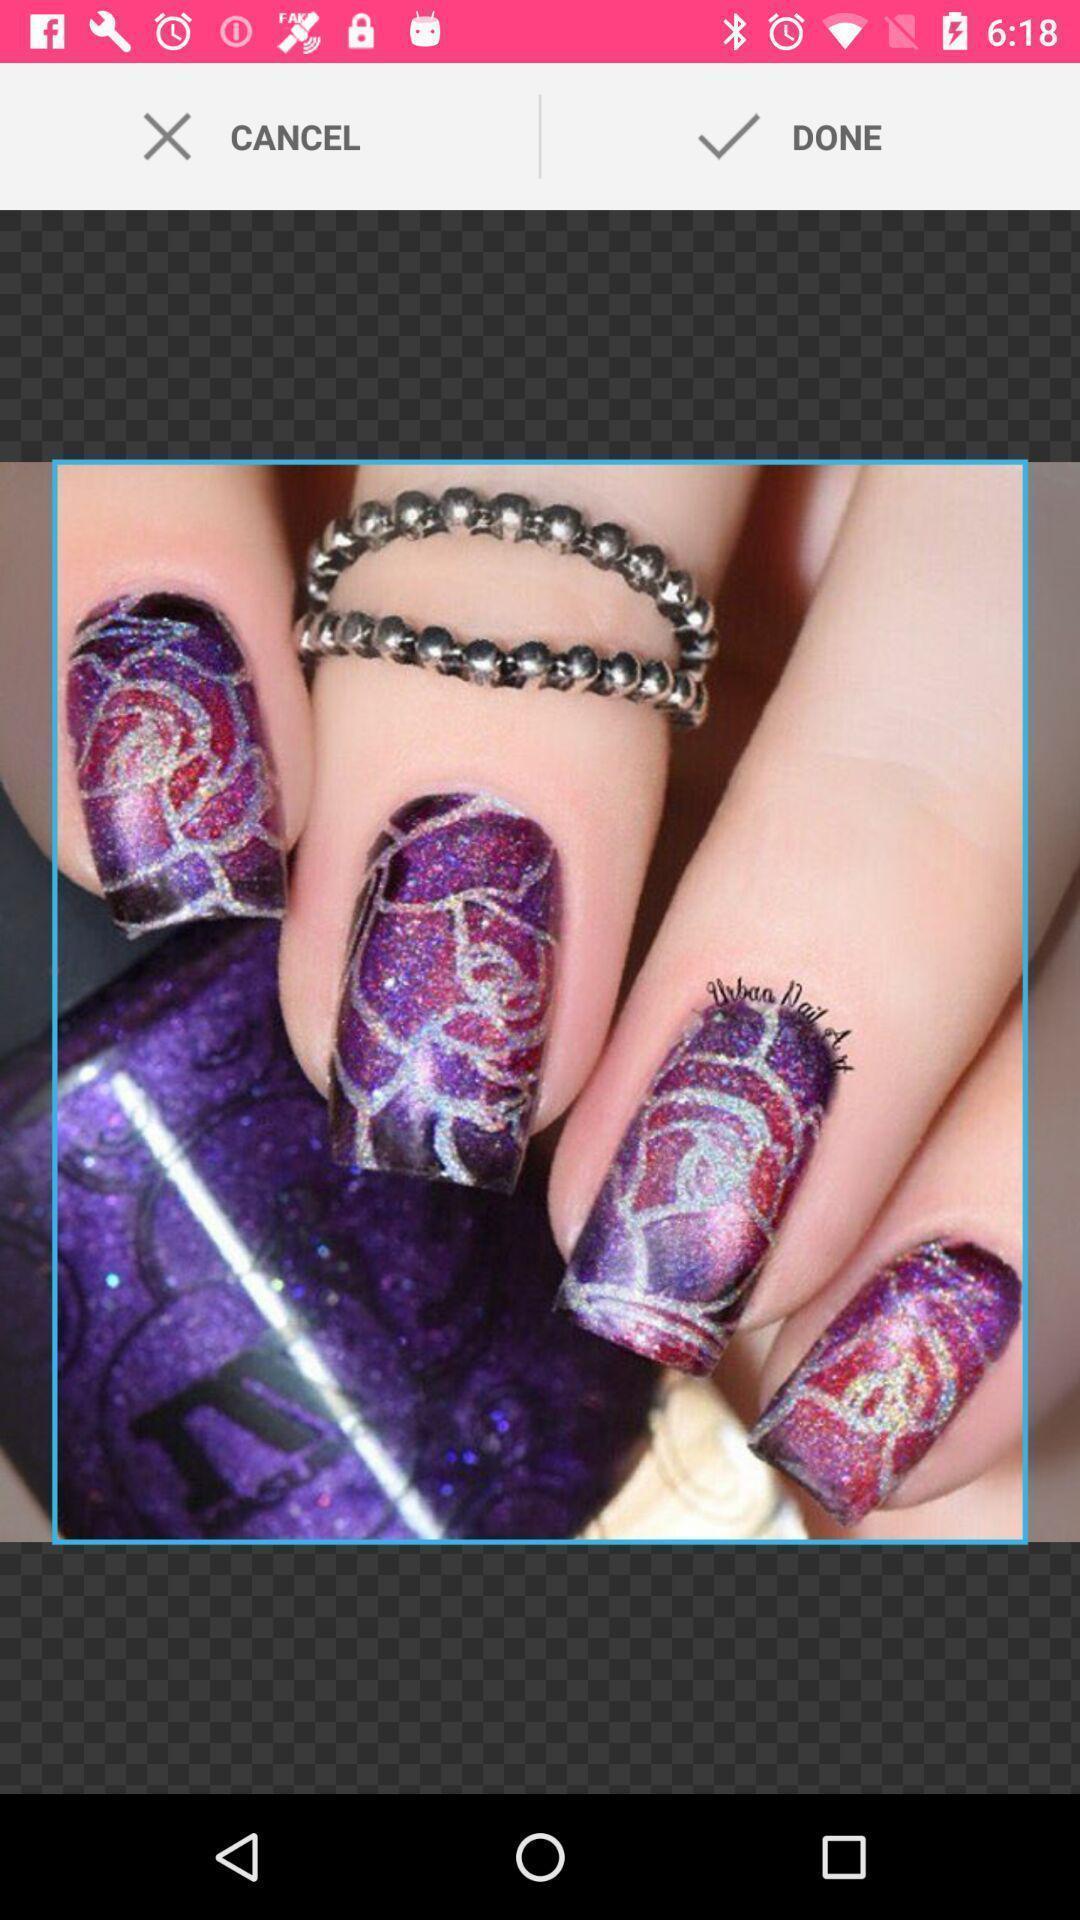Explain what's happening in this screen capture. Screen displaying multiple image editing controls. 